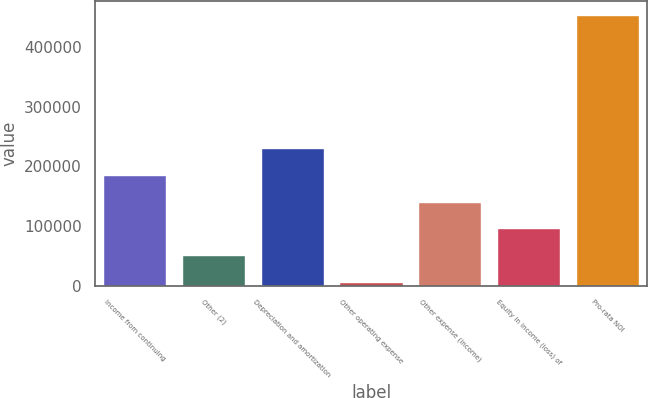Convert chart to OTSL. <chart><loc_0><loc_0><loc_500><loc_500><bar_chart><fcel>Income from continuing<fcel>Other (2)<fcel>Depreciation and amortization<fcel>Other operating expense<fcel>Other expense (income)<fcel>Equity in income (loss) of<fcel>Pro-rata NOI<nl><fcel>185574<fcel>51297.7<fcel>230332<fcel>6539<fcel>140815<fcel>96056.4<fcel>454126<nl></chart> 